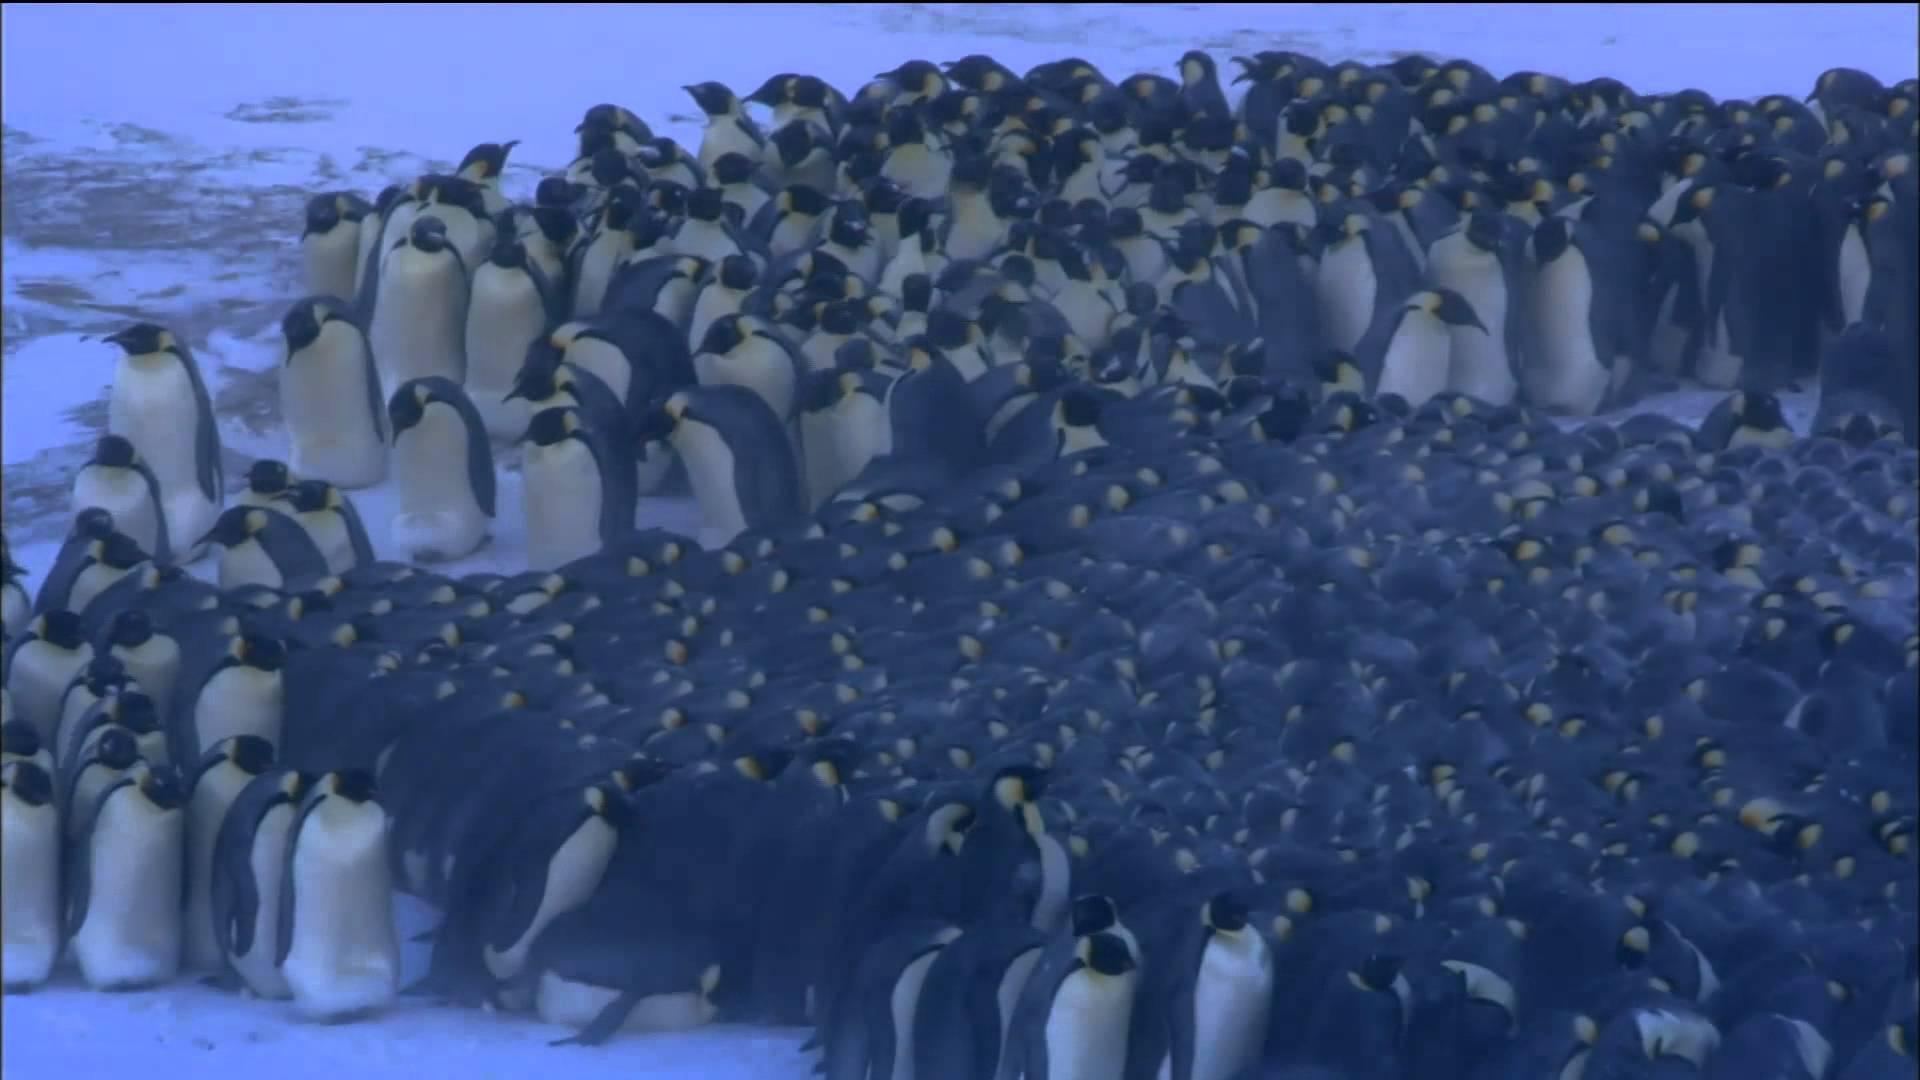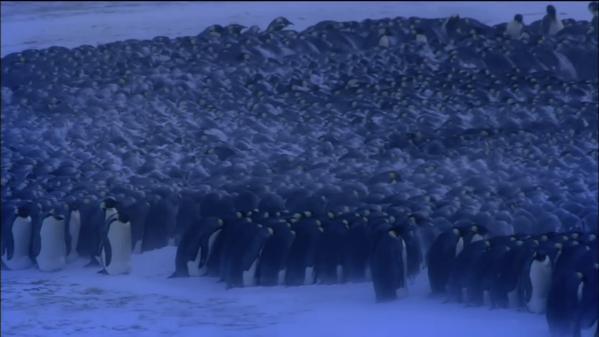The first image is the image on the left, the second image is the image on the right. For the images shown, is this caption "There are penguins huddled in the center of the images." true? Answer yes or no. Yes. The first image is the image on the left, the second image is the image on the right. For the images displayed, is the sentence "In one image the penguins are all huddled together and there is snow on the backs of the outermost penguins." factually correct? Answer yes or no. No. 